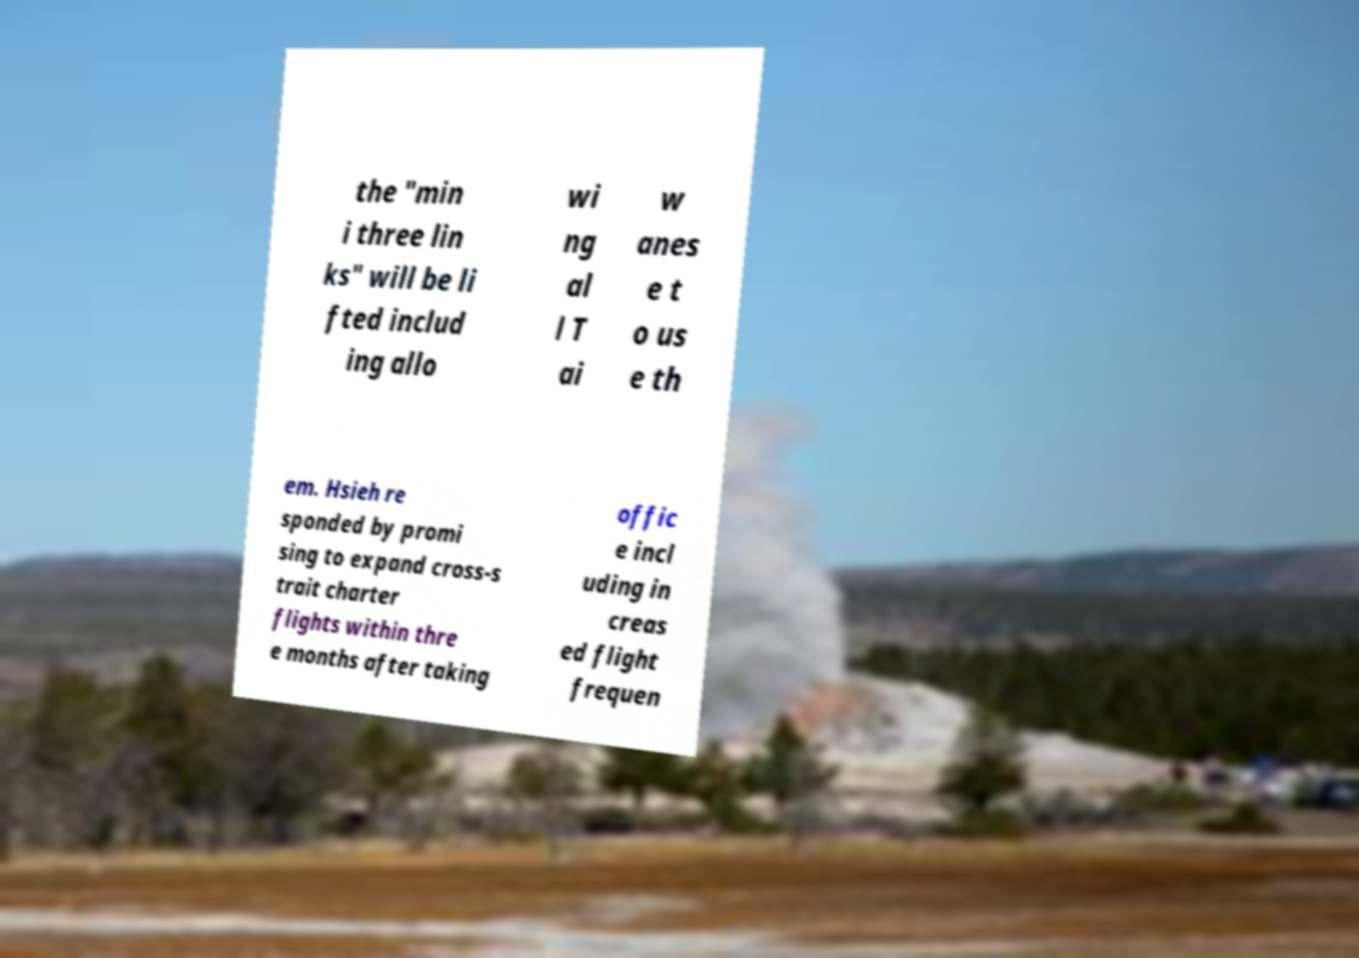I need the written content from this picture converted into text. Can you do that? the "min i three lin ks" will be li fted includ ing allo wi ng al l T ai w anes e t o us e th em. Hsieh re sponded by promi sing to expand cross-s trait charter flights within thre e months after taking offic e incl uding in creas ed flight frequen 